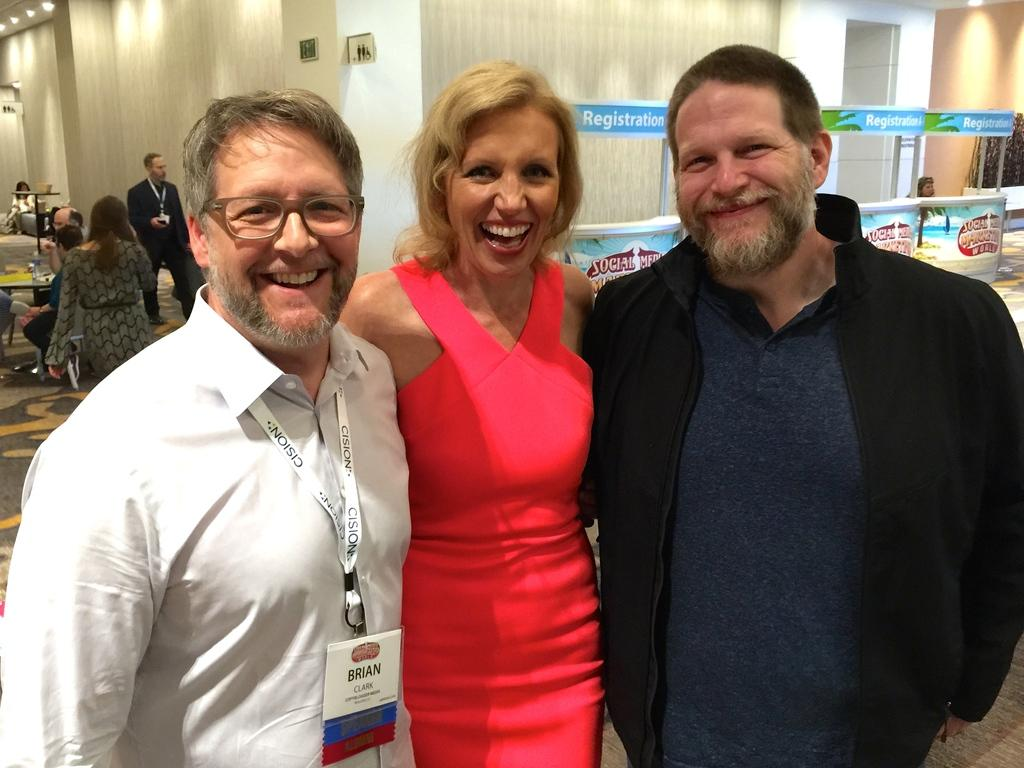How many people are in the image? There are three persons in the image. What is the facial expression of the persons? The persons have smiling faces. What can be seen in the background of the image? There are boards with texts and lights visible in the background. Are there any other people in the image besides the three main subjects? Yes, there are people in the background. Can you see a basket being used by the kitten in the image? There is no kitten or basket present in the image. 